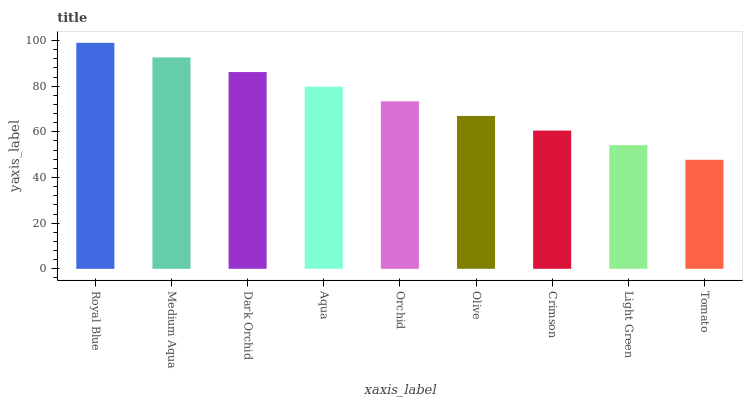Is Tomato the minimum?
Answer yes or no. Yes. Is Royal Blue the maximum?
Answer yes or no. Yes. Is Medium Aqua the minimum?
Answer yes or no. No. Is Medium Aqua the maximum?
Answer yes or no. No. Is Royal Blue greater than Medium Aqua?
Answer yes or no. Yes. Is Medium Aqua less than Royal Blue?
Answer yes or no. Yes. Is Medium Aqua greater than Royal Blue?
Answer yes or no. No. Is Royal Blue less than Medium Aqua?
Answer yes or no. No. Is Orchid the high median?
Answer yes or no. Yes. Is Orchid the low median?
Answer yes or no. Yes. Is Aqua the high median?
Answer yes or no. No. Is Dark Orchid the low median?
Answer yes or no. No. 